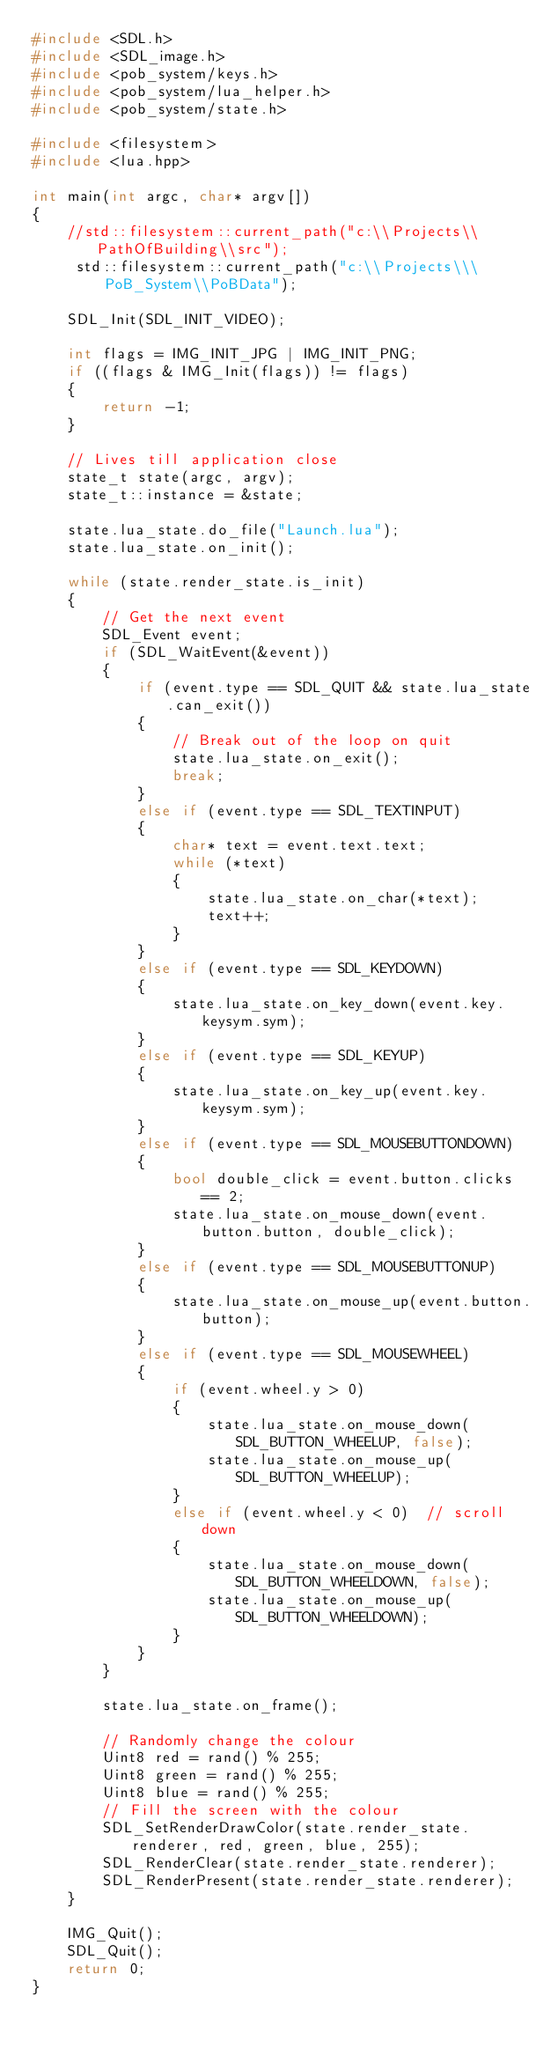Convert code to text. <code><loc_0><loc_0><loc_500><loc_500><_C++_>#include <SDL.h>
#include <SDL_image.h>
#include <pob_system/keys.h>
#include <pob_system/lua_helper.h>
#include <pob_system/state.h>

#include <filesystem>
#include <lua.hpp>

int main(int argc, char* argv[])
{
    //std::filesystem::current_path("c:\\Projects\\PathOfBuilding\\src");
     std::filesystem::current_path("c:\\Projects\\\PoB_System\\PoBData");

    SDL_Init(SDL_INIT_VIDEO);

    int flags = IMG_INIT_JPG | IMG_INIT_PNG;
    if ((flags & IMG_Init(flags)) != flags)
    {
        return -1;
    }

    // Lives till application close
    state_t state(argc, argv);
    state_t::instance = &state;

    state.lua_state.do_file("Launch.lua");
    state.lua_state.on_init();

    while (state.render_state.is_init)
    {
        // Get the next event
        SDL_Event event;
        if (SDL_WaitEvent(&event))
        {
            if (event.type == SDL_QUIT && state.lua_state.can_exit())
            {
                // Break out of the loop on quit
                state.lua_state.on_exit();
                break;
            }
            else if (event.type == SDL_TEXTINPUT)
            {
                char* text = event.text.text;
                while (*text)
                {
                    state.lua_state.on_char(*text);
                    text++;
                }
            }
            else if (event.type == SDL_KEYDOWN)
            {
                state.lua_state.on_key_down(event.key.keysym.sym);
            }
            else if (event.type == SDL_KEYUP)
            {
                state.lua_state.on_key_up(event.key.keysym.sym);
            }
            else if (event.type == SDL_MOUSEBUTTONDOWN)
            {
                bool double_click = event.button.clicks == 2;
                state.lua_state.on_mouse_down(event.button.button, double_click);
            }
            else if (event.type == SDL_MOUSEBUTTONUP)
            {
                state.lua_state.on_mouse_up(event.button.button);
            }
            else if (event.type == SDL_MOUSEWHEEL)
            {
                if (event.wheel.y > 0)
                {
                    state.lua_state.on_mouse_down(SDL_BUTTON_WHEELUP, false);
                    state.lua_state.on_mouse_up(SDL_BUTTON_WHEELUP);
                }
                else if (event.wheel.y < 0)  // scroll down
                {
                    state.lua_state.on_mouse_down(SDL_BUTTON_WHEELDOWN, false);
                    state.lua_state.on_mouse_up(SDL_BUTTON_WHEELDOWN);
                }
            }
        }

        state.lua_state.on_frame();

        // Randomly change the colour
        Uint8 red = rand() % 255;
        Uint8 green = rand() % 255;
        Uint8 blue = rand() % 255;
        // Fill the screen with the colour
        SDL_SetRenderDrawColor(state.render_state.renderer, red, green, blue, 255);
        SDL_RenderClear(state.render_state.renderer);
        SDL_RenderPresent(state.render_state.renderer);
    }

    IMG_Quit();
    SDL_Quit();
    return 0;
}</code> 